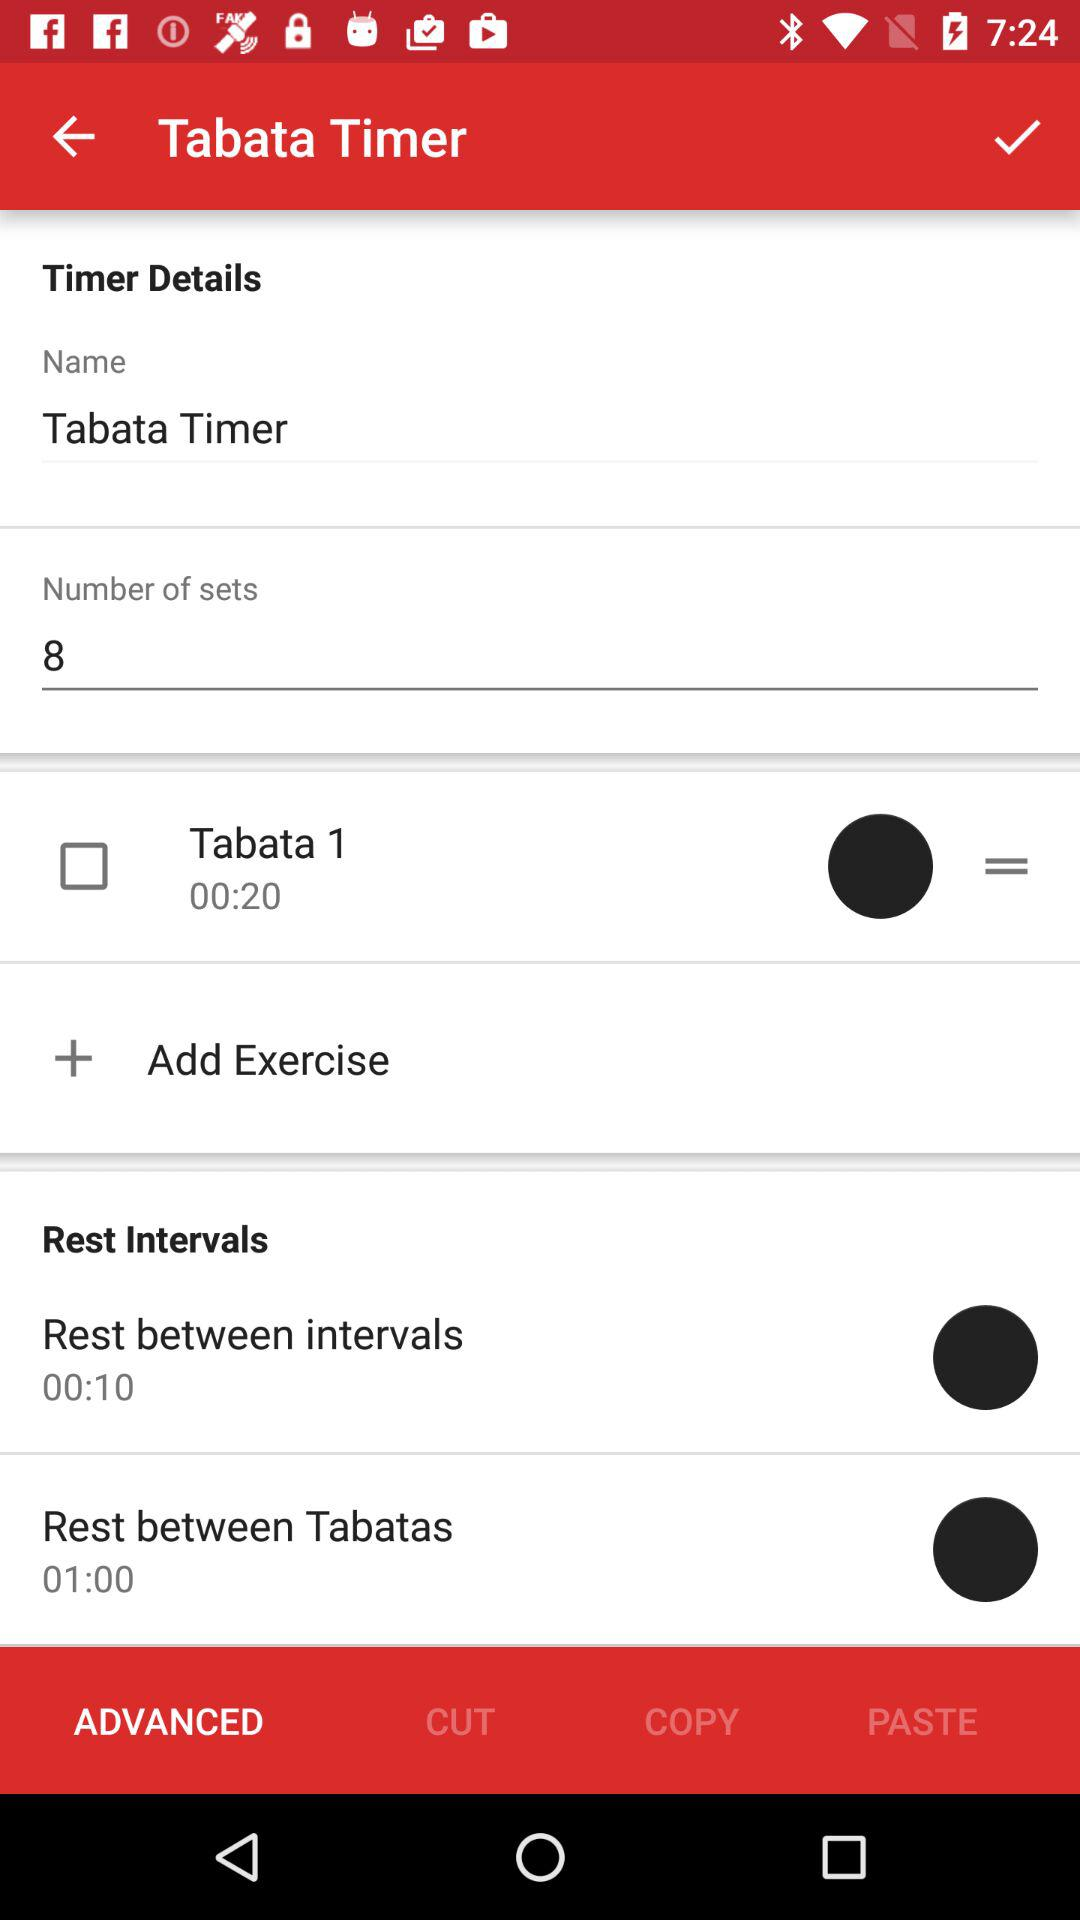What is the name of the timer? The name of the timer is "Tabata Timer". 